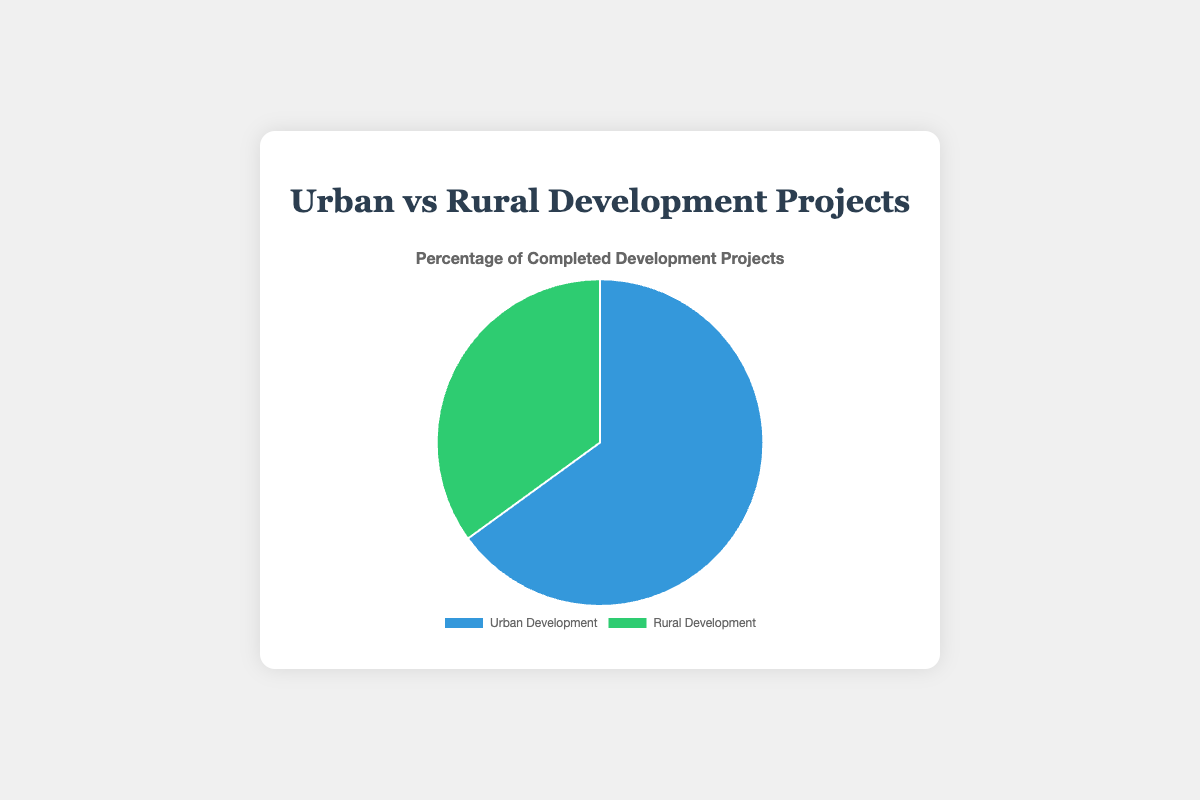What percentage of development projects were completed in urban areas? The pie chart data shows that urban development projects account for a specific portion of the total. By inspecting the chart, it is clear that 65% of the projects were completed in urban areas.
Answer: 65% What percentage of development projects were completed in rural areas? According to the pie chart, rural development projects make up a certain percentage of the total. It's evident from the chart that 35% of the projects were completed in rural areas.
Answer: 35% Which type of development projects had a higher completion rate? By comparing the segments, the urban development projects have a larger portion compared to the rural development projects. Therefore, urban development had a higher completion rate.
Answer: Urban Development What is the difference in completion rates between urban and rural development projects? To find the difference, subtract the percentage of rural development projects (35%) from the urban development projects (65%). Therefore, 65% - 35% = 30%.
Answer: 30% If the total number of projects is 100, how many were urban development projects? Since urban development accounts for 65%, multiplying this percentage by the total number of projects (100) gives 65%. So, 65% of 100 is 65 projects.
Answer: 65 What fraction of the total projects were rural development projects? Convert the percentage of rural development projects (35%) to a fraction by dividing by 100. This fraction is 35/100, which simplifies to 7/20.
Answer: 7/20 How many times larger is the proportion of urban projects compared to rural projects? To find how many times larger urban projects are compared to rural, divide the percentage of urban projects (65%) by the percentage of rural projects (35%). So, 65 / 35 ≈ 1.86 times.
Answer: 1.86 times What color represents urban development projects in the chart? The pie chart visually represents different categories with colors. The segment for urban development projects is colored blue.
Answer: Blue Which segment has a larger visual area in the pie chart? Visually, the urban development segment occupies a larger area of the pie chart compared to the rural development segment.
Answer: Urban Development If the completion rate of urban projects needs to increase by 10% to achieve a specific goal, what would the new percentage be? Increasing the completion rate from 65% by 10% involves adding 10 to 65. Therefore, 65% + 10% = 75%.
Answer: 75% 